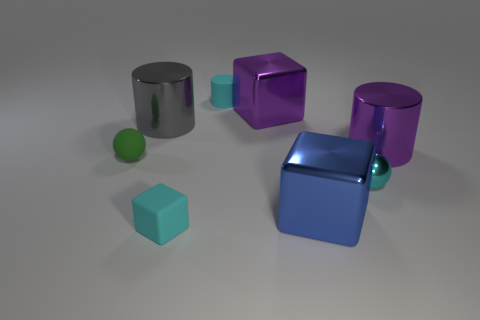Is the shape of the cyan shiny object the same as the purple thing behind the big gray thing?
Your response must be concise. No. What size is the blue block that is made of the same material as the big gray object?
Keep it short and to the point. Large. Is there any other thing that is the same color as the matte sphere?
Your answer should be compact. No. What is the cyan object behind the large purple metal object that is in front of the large object that is left of the cyan cylinder made of?
Your response must be concise. Rubber. What number of rubber things are either tiny cylinders or spheres?
Provide a short and direct response. 2. Does the matte cylinder have the same color as the tiny metallic ball?
Your answer should be very brief. Yes. What number of objects are either tiny blue rubber spheres or tiny objects behind the large purple shiny cylinder?
Offer a very short reply. 1. Does the cylinder right of the cyan cylinder have the same size as the tiny green sphere?
Offer a very short reply. No. How many other objects are there of the same shape as the large gray metallic thing?
Make the answer very short. 2. What number of purple things are either big cylinders or cylinders?
Offer a terse response. 1. 